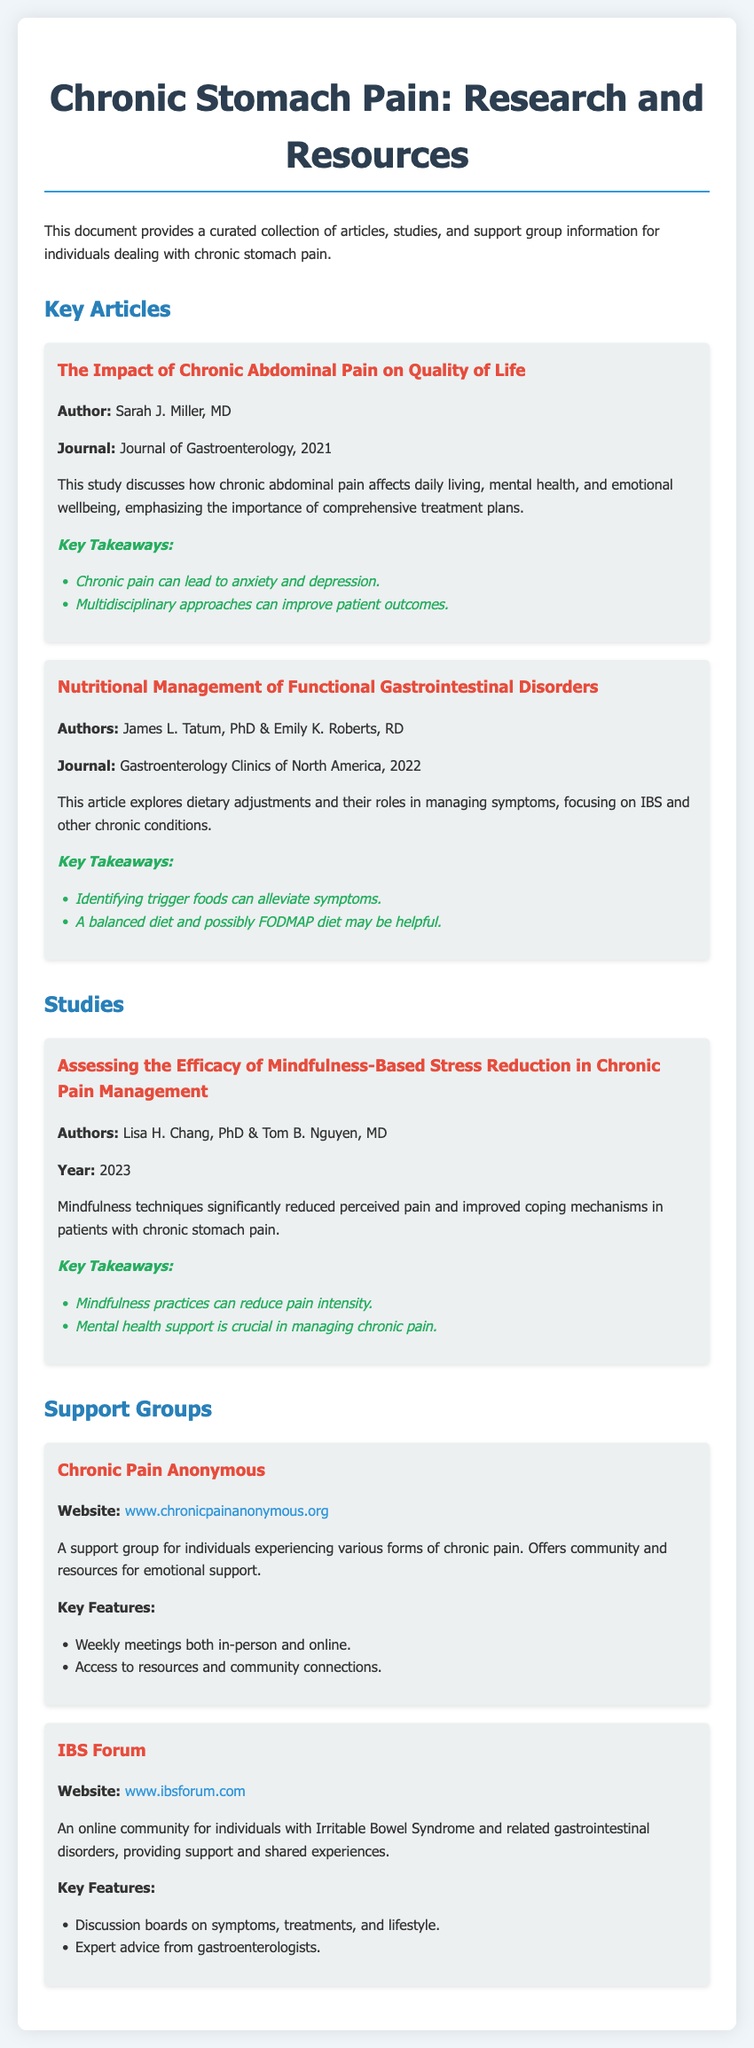what is the title of the first article? The title of the first article is mentioned in the document as "The Impact of Chronic Abdominal Pain on Quality of Life."
Answer: The Impact of Chronic Abdominal Pain on Quality of Life who is the author of the study on mindfulness-based stress reduction? The author of the study is listed in the document as Lisa H. Chang, PhD & Tom B. Nguyen, MD.
Answer: Lisa H. Chang, PhD & Tom B. Nguyen, MD what year was the article on nutritional management published? The publication year for the article on nutritional management is provided as 2022 in the document.
Answer: 2022 how many key takeaways are listed for the study on mindfulness? The document lists two key takeaways for the study on mindfulness practices.
Answer: 2 what type of support group is Chronic Pain Anonymous? The type of support group is categorized as a support group for individuals experiencing various forms of chronic pain in the document.
Answer: Chronic Pain Anonymous what is one of the key features of the IBS Forum support group? One of the key features mentioned for the IBS Forum is discussion boards on symptoms, treatments, and lifestyle.
Answer: Discussion boards on symptoms, treatments, and lifestyle what journal published the article on the impact of chronic abdominal pain? The journal for the article on the impact of chronic abdominal pain is identified as the Journal of Gastroenterology in the document.
Answer: Journal of Gastroenterology how can mindfulness practices help patients? The document states that mindfulness practices can reduce pain intensity for patients with chronic stomach pain.
Answer: Reduce pain intensity 